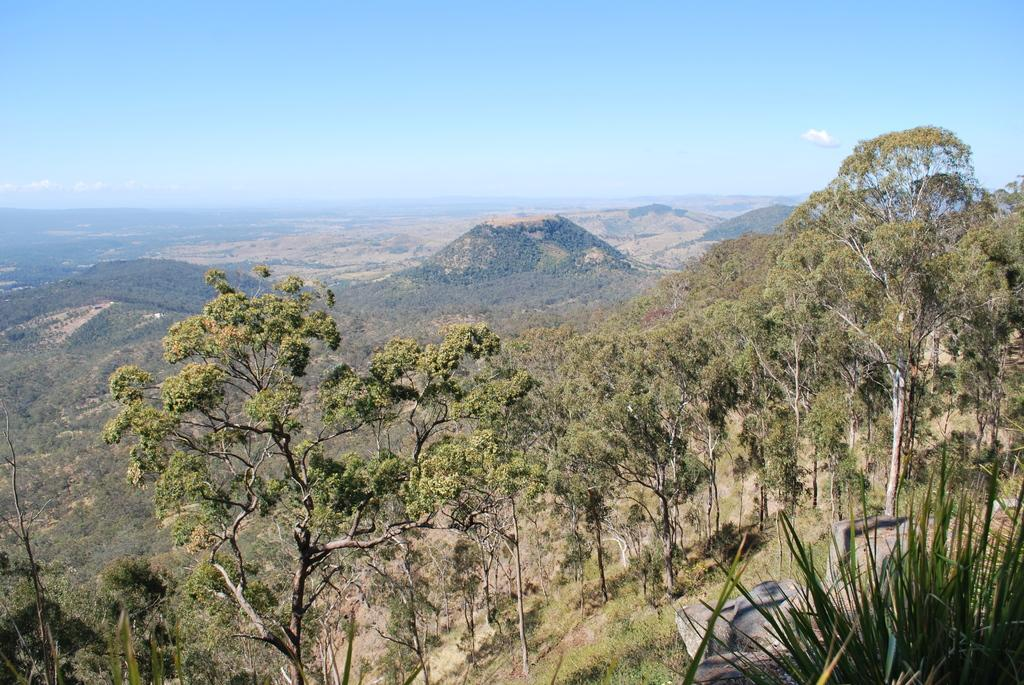What type of vegetation can be seen in the image? There are plants and trees in the image. What can be seen in the background of the image? There are hills visible in the background of the image. What is visible at the top of the image? The sky is visible in the image. What type of cord is hanging from the trees in the image? There is no cord hanging from the trees in the image; only plants, trees, hills, and the sky are present. What smell can be detected from the plants in the image? The image does not provide any information about the smell of the plants, as it only shows visual details. 